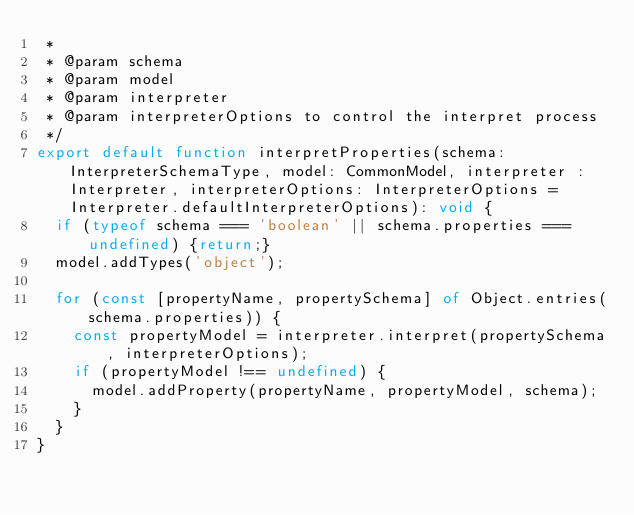<code> <loc_0><loc_0><loc_500><loc_500><_TypeScript_> * 
 * @param schema
 * @param model
 * @param interpreter
 * @param interpreterOptions to control the interpret process
 */
export default function interpretProperties(schema: InterpreterSchemaType, model: CommonModel, interpreter : Interpreter, interpreterOptions: InterpreterOptions = Interpreter.defaultInterpreterOptions): void {
  if (typeof schema === 'boolean' || schema.properties === undefined) {return;}
  model.addTypes('object');
  
  for (const [propertyName, propertySchema] of Object.entries(schema.properties)) {
    const propertyModel = interpreter.interpret(propertySchema, interpreterOptions);
    if (propertyModel !== undefined) {
      model.addProperty(propertyName, propertyModel, schema);
    }
  }
}

</code> 